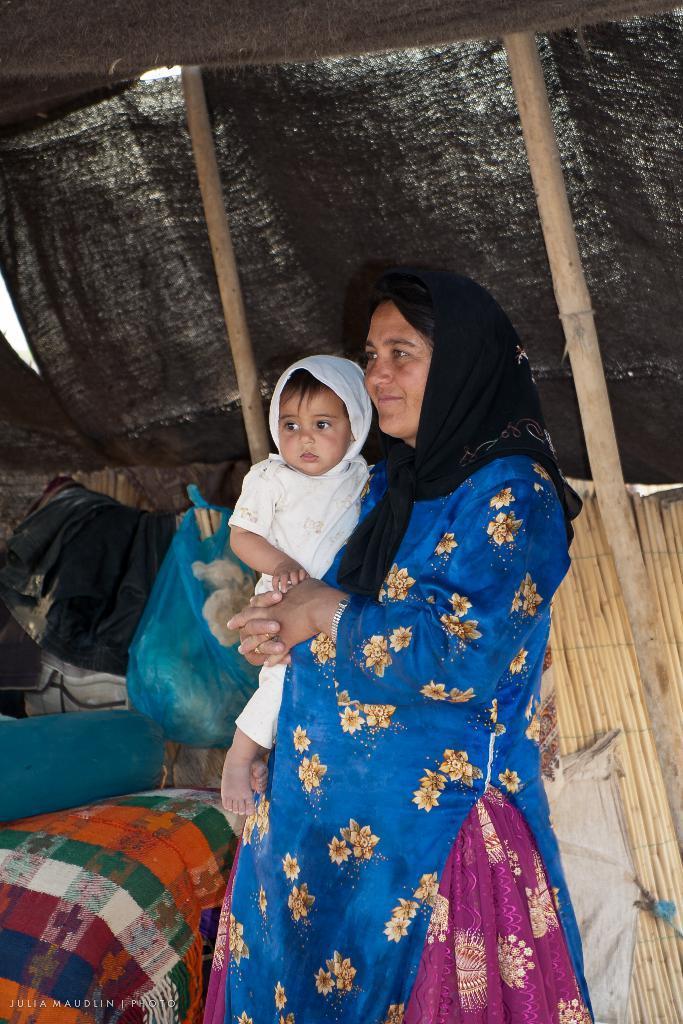In one or two sentences, can you explain what this image depicts? In the center of the image we can see one woman is standing and she is smiling and she is holding one baby. And we can see she is in a different costume. At the bottom left side of the image, we can see some text. In the background, we can see poles, wooden wall, cloth, one plastic cover, backpacks, one blanket, one blue color object and a few other objects. 